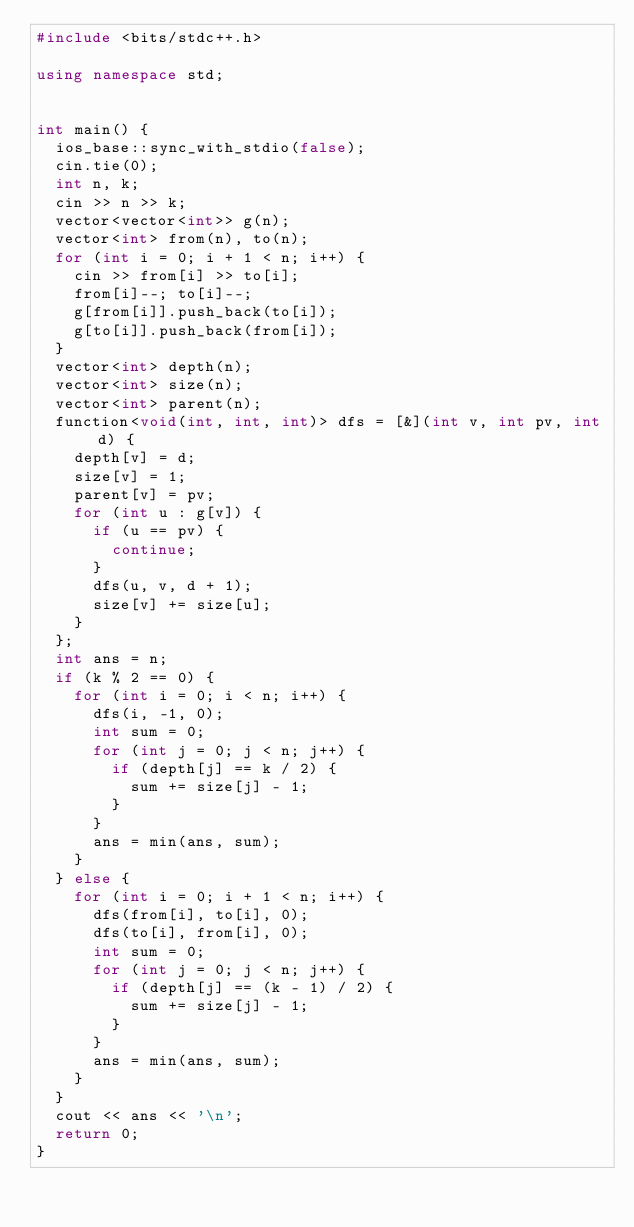<code> <loc_0><loc_0><loc_500><loc_500><_C++_>#include <bits/stdc++.h>

using namespace std;


int main() {
  ios_base::sync_with_stdio(false);
  cin.tie(0);
  int n, k;
  cin >> n >> k;
  vector<vector<int>> g(n);
  vector<int> from(n), to(n);
  for (int i = 0; i + 1 < n; i++) {
    cin >> from[i] >> to[i];
    from[i]--; to[i]--;
    g[from[i]].push_back(to[i]);
    g[to[i]].push_back(from[i]);
  }
  vector<int> depth(n);
  vector<int> size(n);
  vector<int> parent(n);
  function<void(int, int, int)> dfs = [&](int v, int pv, int d) {
    depth[v] = d;
    size[v] = 1;
    parent[v] = pv;
    for (int u : g[v]) {
      if (u == pv) {
        continue;
      }
      dfs(u, v, d + 1);
      size[v] += size[u];
    }
  };
  int ans = n;
  if (k % 2 == 0) {
    for (int i = 0; i < n; i++) {
      dfs(i, -1, 0);
      int sum = 0;
      for (int j = 0; j < n; j++) {
        if (depth[j] == k / 2) {
          sum += size[j] - 1;
        }
      }
      ans = min(ans, sum);
    }
  } else {
    for (int i = 0; i + 1 < n; i++) {
      dfs(from[i], to[i], 0);
      dfs(to[i], from[i], 0);
      int sum = 0;
      for (int j = 0; j < n; j++) {
        if (depth[j] == (k - 1) / 2) {
          sum += size[j] - 1;
        }
      }
      ans = min(ans, sum);
    }
  }
  cout << ans << '\n';
  return 0;
}</code> 